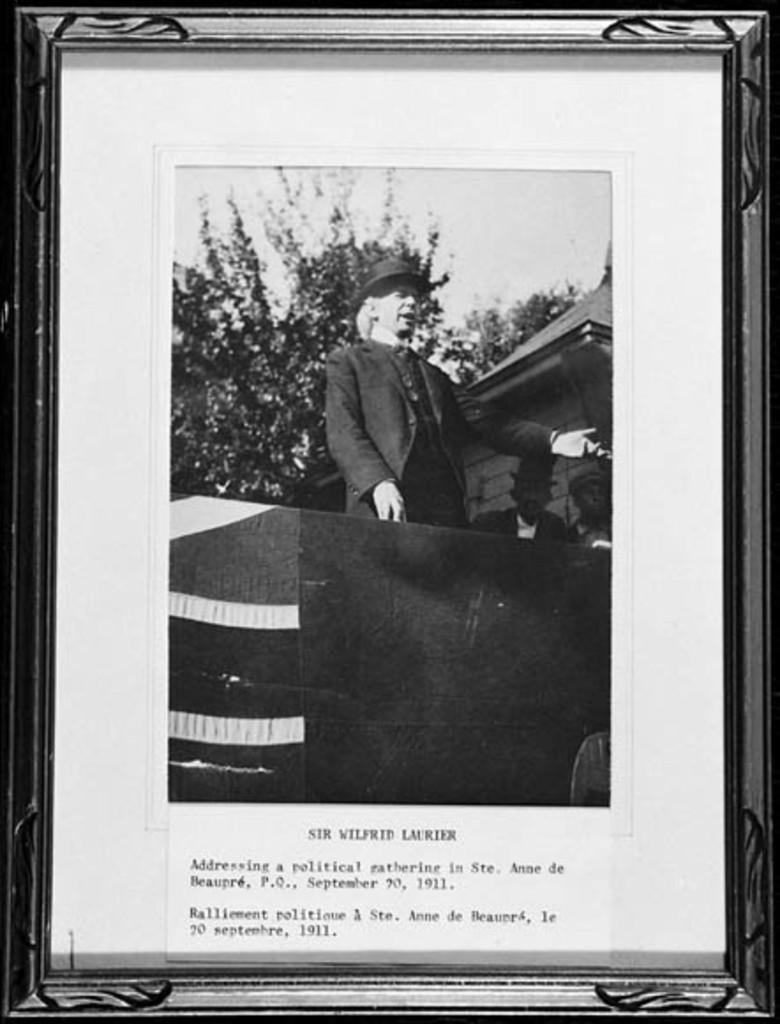What is the title of photo?
Provide a short and direct response. Sir wilfrid laurier. What is the name of the person pictured?
Give a very brief answer. Sir wilfred laurier. 